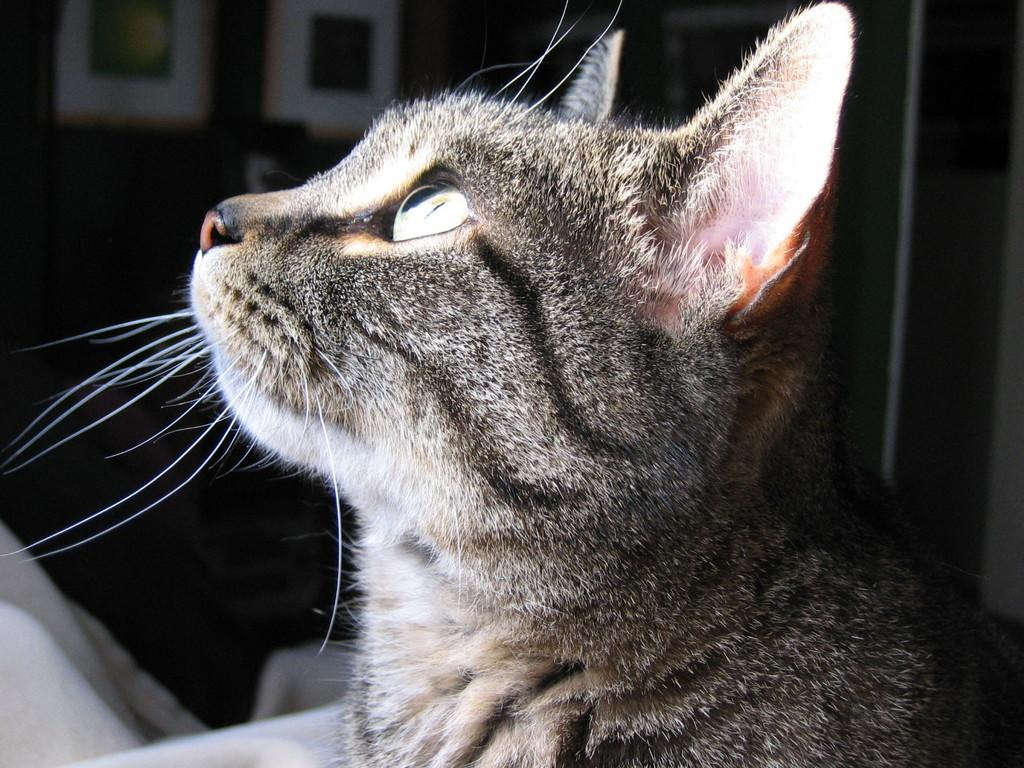What animal is present in the image? There is a cat in the image. What is the cat doing in the image? The cat is looking upwards. Can you describe the background of the image? The background of the image is dark. What type of beam is holding up the ceiling in the image? There is no beam visible in the image, as it features a cat looking upwards with a dark background. 